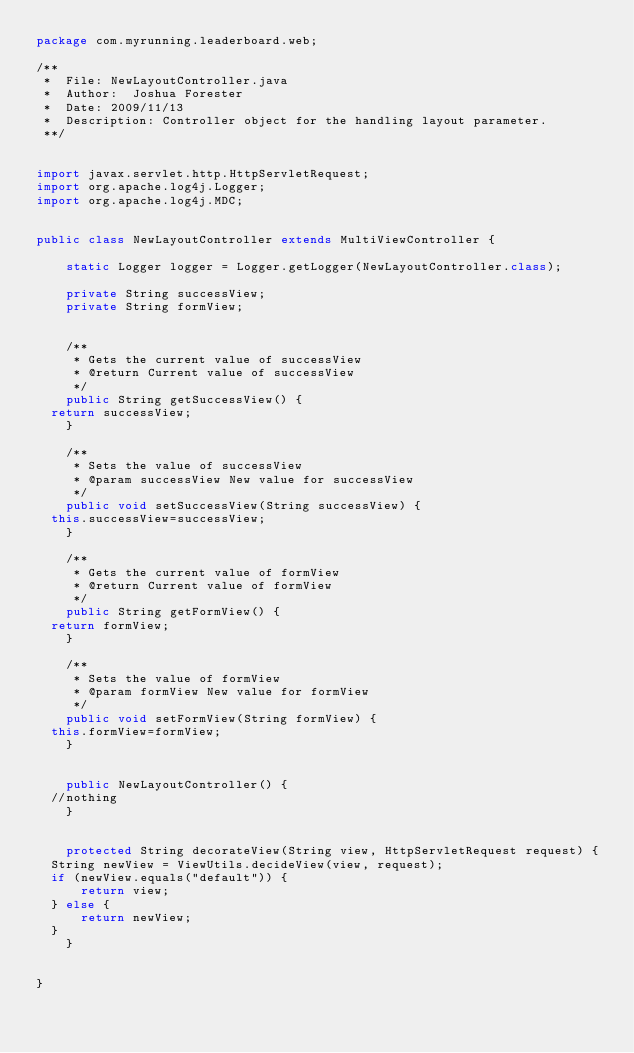<code> <loc_0><loc_0><loc_500><loc_500><_Java_>package com.myrunning.leaderboard.web;

/**
 *  File: NewLayoutController.java
 *  Author:  Joshua Forester
 *  Date: 2009/11/13
 *  Description: Controller object for the handling layout parameter.
 **/


import javax.servlet.http.HttpServletRequest;
import org.apache.log4j.Logger;
import org.apache.log4j.MDC;


public class NewLayoutController extends MultiViewController {

    static Logger logger = Logger.getLogger(NewLayoutController.class);

    private String successView;
    private String formView;

    
    /**
     * Gets the current value of successView
     * @return Current value of successView
     */
    public String getSuccessView() {
	return successView;
    }

    /**
     * Sets the value of successView
     * @param successView New value for successView
     */
    public void setSuccessView(String successView) {
	this.successView=successView;
    }

    /**
     * Gets the current value of formView
     * @return Current value of formView
     */
    public String getFormView() {
	return formView;
    }
    
    /**
     * Sets the value of formView
     * @param formView New value for formView
     */
    public void setFormView(String formView) {
	this.formView=formView;
    }


    public NewLayoutController() {
	//nothing
    }
    

    protected String decorateView(String view, HttpServletRequest request) {
	String newView = ViewUtils.decideView(view, request);
	if (newView.equals("default")) {
	    return view;
	} else {
	    return newView;
	}
    }


}
</code> 